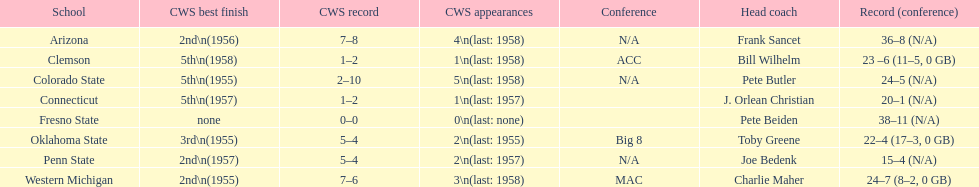List the schools that came in last place in the cws best finish. Clemson, Colorado State, Connecticut. 